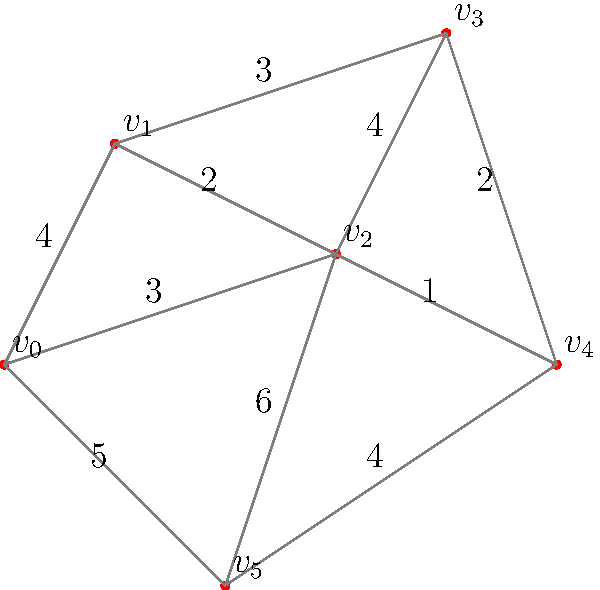As an entrepreneur planning an opera house, you're tasked with designing an efficient backstage area layout. The graph represents different sections of the backstage area, where vertices are key locations and edge weights represent the cost of connecting two locations. Using Kruskal's algorithm for finding the minimum spanning tree, determine the total cost of the most efficient layout that connects all locations. How does this approach reflect the entrepreneurial spirit of optimizing resources? Let's approach this step-by-step using Kruskal's algorithm:

1) First, sort all edges by weight in ascending order:
   $(v_2, v_4, 1)$, $(v_1, v_2, 2)$, $(v_3, v_4, 2)$, $(v_0, v_2, 3)$, $(v_1, v_3, 3)$, $(v_0, v_1, 4)$, $(v_2, v_3, 4)$, $(v_4, v_5, 4)$, $(v_0, v_5, 5)$, $(v_2, v_5, 6)$

2) Start with an empty set and add edges that don't create cycles:

   - Add $(v_2, v_4, 1)$. Total cost: 1
   - Add $(v_1, v_2, 2)$. Total cost: 3
   - Add $(v_3, v_4, 2)$. Total cost: 5
   - Add $(v_0, v_2, 3)$. Total cost: 8
   - Add $(v_4, v_5, 4)$. Total cost: 12

3) We've now included all vertices without creating cycles, so we stop.

The minimum spanning tree has a total cost of 12.

This approach reflects the entrepreneurial spirit by:
1) Optimizing resources: Finding the most cost-effective way to connect all areas.
2) Efficiency: Ensuring all areas are connected with minimal redundancy.
3) Strategic planning: Considering the layout holistically to make informed decisions.
4) Innovation: Using advanced algorithms to solve complex logistical problems.

As an entrepreneur in the arts, this demonstrates how business acumen and artistic vision can be combined to create an efficient and inspiring space for opera performances.
Answer: 12 